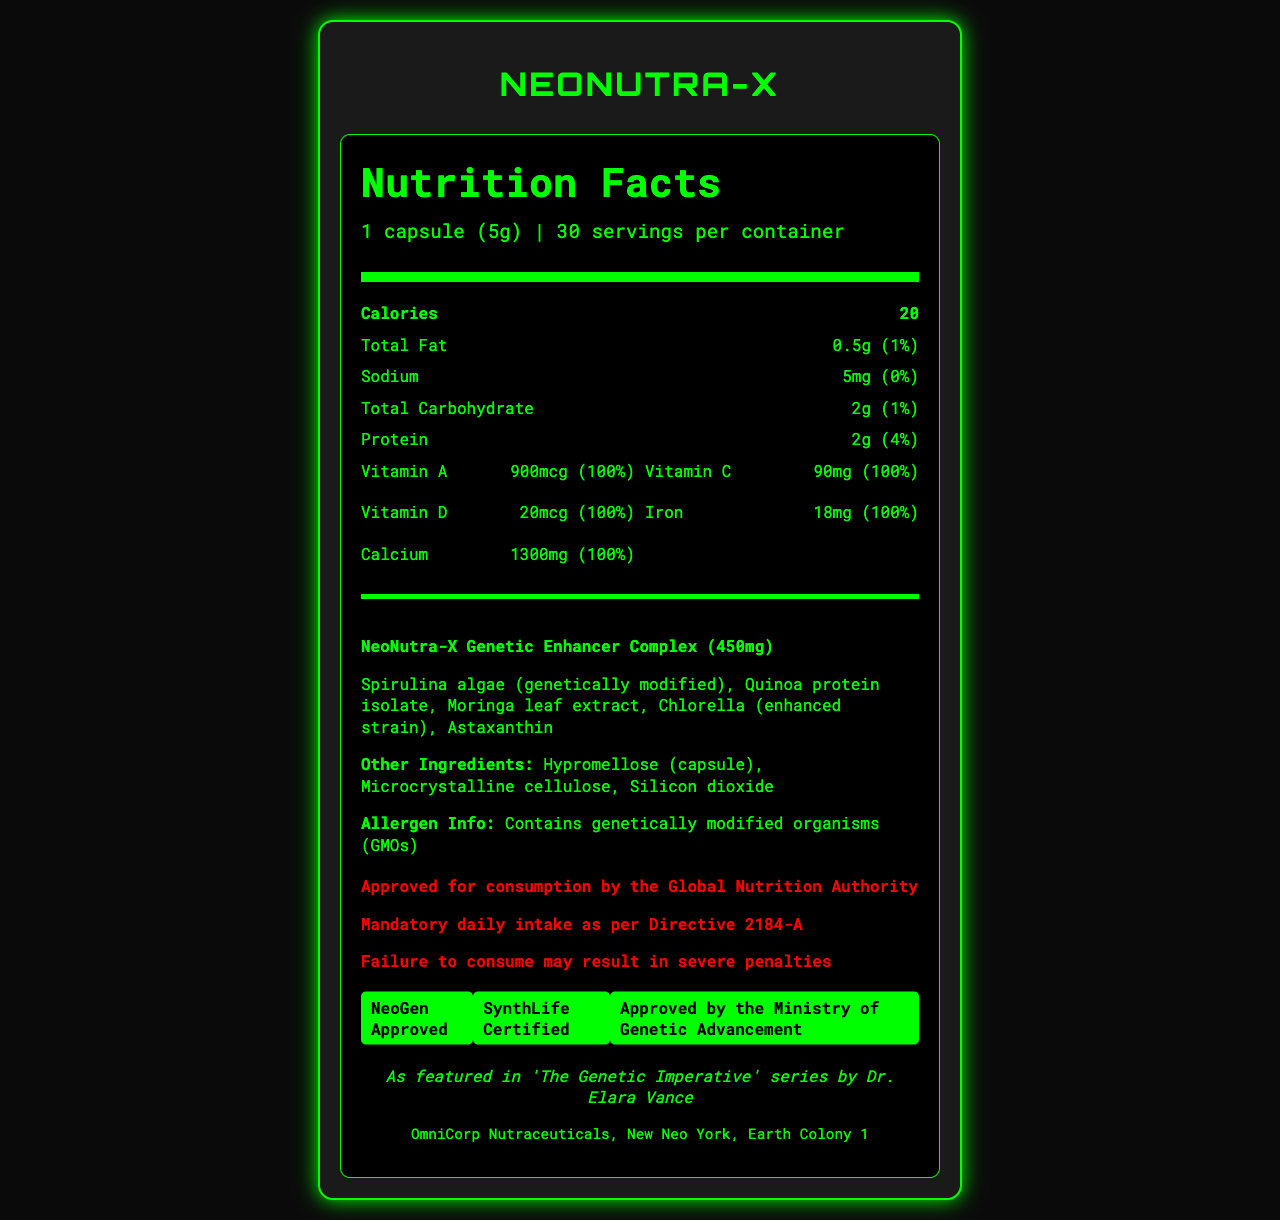what is the serving size for NeoNutra-X? The serving size is clearly mentioned at the top of the nutrition label as "1 capsule (5g)".
Answer: 1 capsule (5g) how many servings are in one container of NeoNutra-X? It is indicated at the top of the nutrition label that there are 30 servings per container.
Answer: 30 how many calories does one serving of NeoNutra-X contain? The number of calories per serving is specified right under the serving information as 20.
Answer: 20 what is the total fat content per serving? The total fat content is listed as "0.5g" in the nutrition facts section.
Answer: 0.5g which ingredient in the proprietary blend is genetically modified? The ingredient list under the "NeoNutra-X Genetic Enhancer Complex" lists "Spirulina algae (genetically modified)".
Answer: Spirulina algae how much Vitamin C does one serving of NeoNutra-X provide? Under the vitamins and minerals section, Vitamin C is listed as providing "90mg".
Answer: 90mg what is the daily value percentage of protein in one serving? In the nutrition item section, protein shows a daily value of 4%.
Answer: 4% which of the following vitamins are included in the NeoNutra-X capsule? (A) Vitamin A, (B) Vitamin E, (C) Vitamin K, (D) Vitamin D The vitamins listed are Vitamin A, Vitamin C, Vitamin D, Iron, and Calcium.
Answer: A and D what is the purpose of Silicon Dioxide in the ingredients? The document lists Silicon Dioxide as an ingredient, but no information is provided about its purpose.
Answer: Not enough information which certification is *not* mentioned in the NeoNutra-X document? (i) NeoGen Approved, (ii) BioLife Certified, (iii) SynthLife Certified, (iv) Approved by the Ministry of Genetic Advancement The certifications listed are NeoGen Approved, SynthLife Certified, and Approved by the Ministry of Genetic Advancement.
Answer: ii is the NeoNutra-X product approved for consumption by the Global Nutrition Authority? One of the dystopian warnings clearly states "Approved for consumption by the Global Nutrition Authority".
Answer: Yes summarize the main idea of the document. The document provides a comprehensive summary of NeoNutra-X, including detailed nutritional facts, a proprietary blend of genetically modified ingredients, necessary warnings, certifications, and references to its appearance in the dystopian book series 'The Genetic Imperative'.
Answer: An overview of NeoNutra-X, a genetically modified superfood capsule, outlining its nutritional information, serving size, proprietary blend ingredients, allergen info, dystopian warnings, and certifications. what is the warning issued if one fails to consume NeoNutra-X as per the directive? One of the dystopian warnings listed is "Failure to consume may result in severe penalties".
Answer: Failure to consume may result in severe penalties 